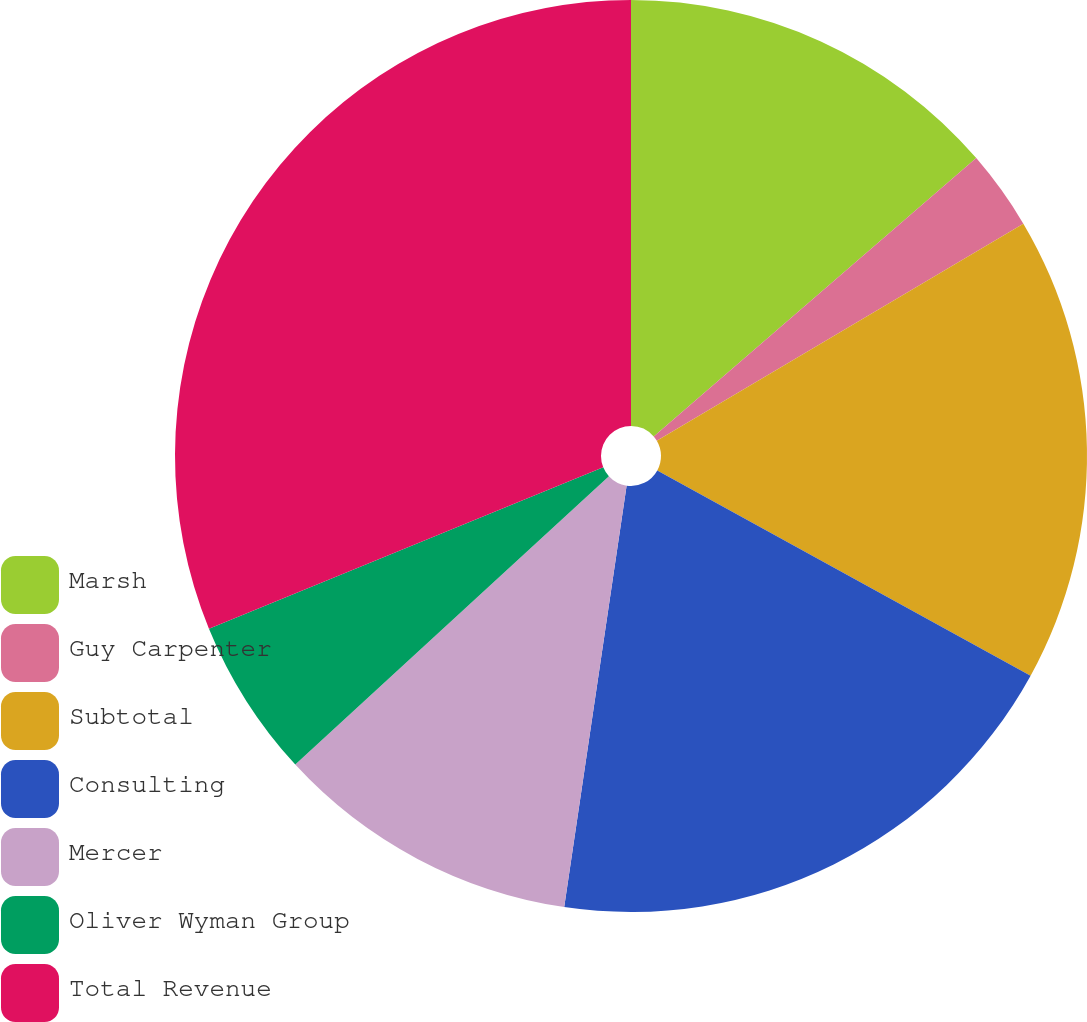<chart> <loc_0><loc_0><loc_500><loc_500><pie_chart><fcel>Marsh<fcel>Guy Carpenter<fcel>Subtotal<fcel>Consulting<fcel>Mercer<fcel>Oliver Wyman Group<fcel>Total Revenue<nl><fcel>13.67%<fcel>2.82%<fcel>16.51%<fcel>19.34%<fcel>10.83%<fcel>5.65%<fcel>31.18%<nl></chart> 